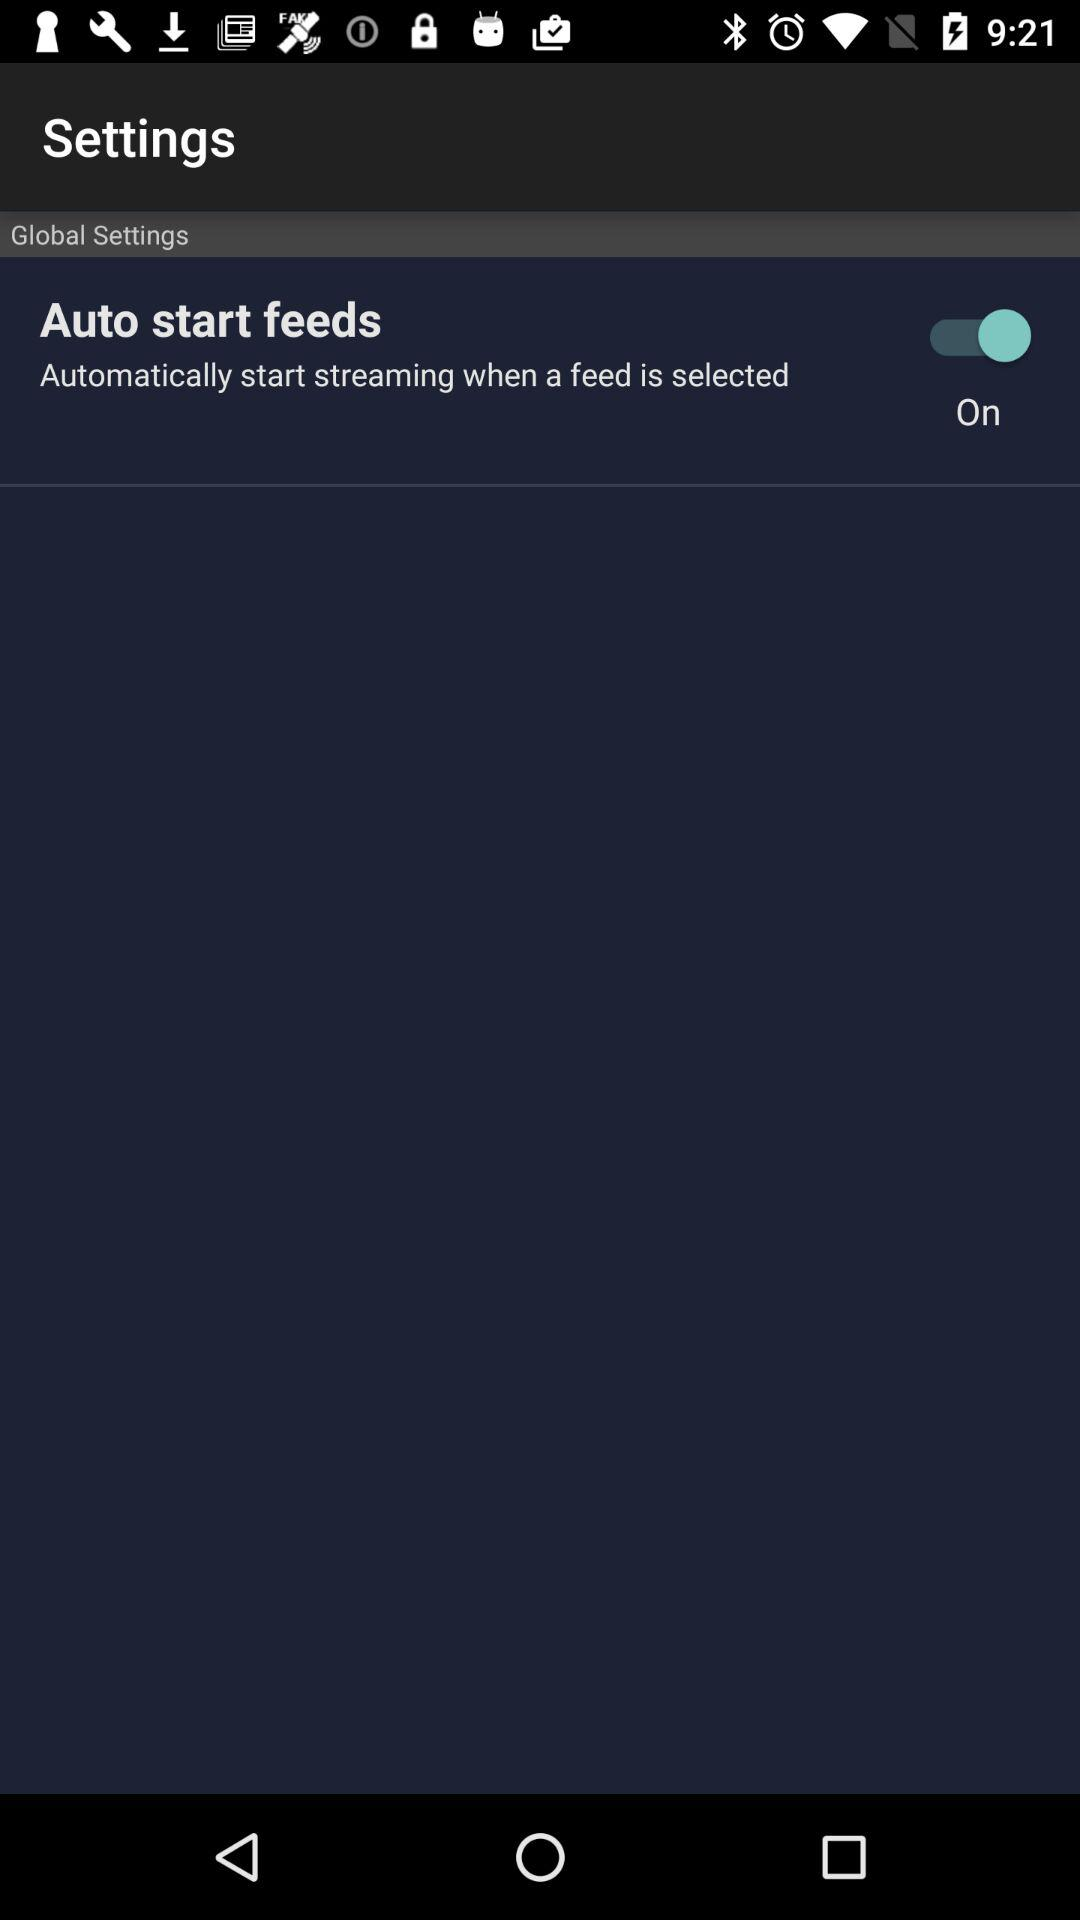What is the status of "Auto start feeds"? The status is "on". 